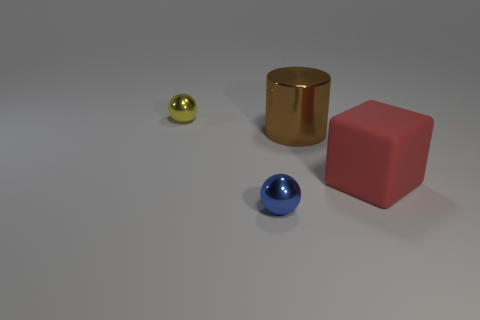Could you describe the texture differences between the objects? Certainly, the blue sphere and gold cylinder have a reflective, possibly metallic texture, which is indicated by the highlights and sharp reflections on their surfaces. The yellow sphere seems to share a similar texture, albeit its smaller size makes the effect less pronounced. In contrast, the pink cube exhibits a distinctly matte finish, absorbing rather than reflecting light, giving it a softer appearance. 